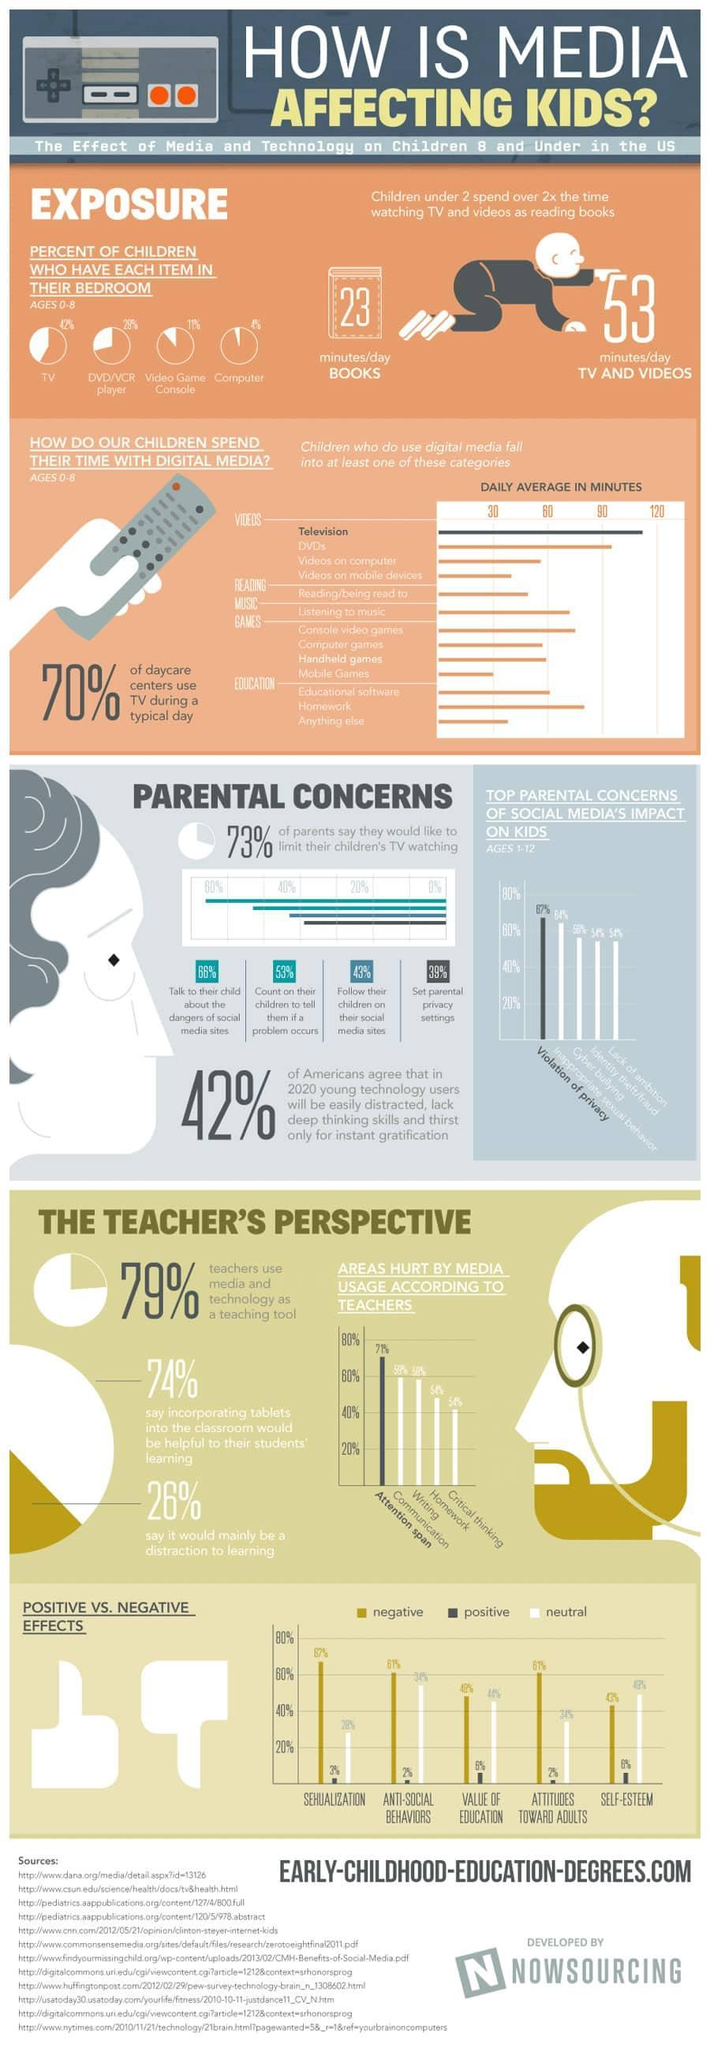What % of parents follow their children on their social media sites
Answer the question with a short phrase. 43% On what do children spend more than 1.5 hours daily on an average television, dvds what is the colour of the dress of the toddler, red or blue blue What are more than 60% parents concerned of social media's impact on kids Violation of privacy, Inappropriate sexual behavior How much more minutes / day do children under 2 spend on TV and videos than on books 20 What % of children have a video game console in their bedroom 11 WHich are the 2 main areas hurt by media usage according to 58%-60%  of teachers Communication, Writing 